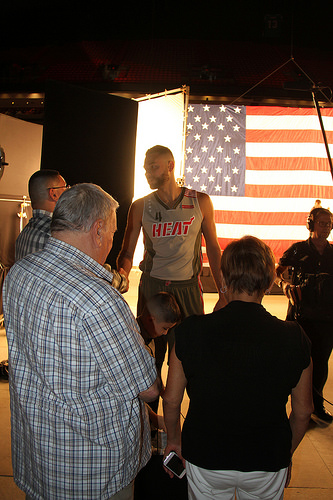<image>
Is the shirt on the man? No. The shirt is not positioned on the man. They may be near each other, but the shirt is not supported by or resting on top of the man. 